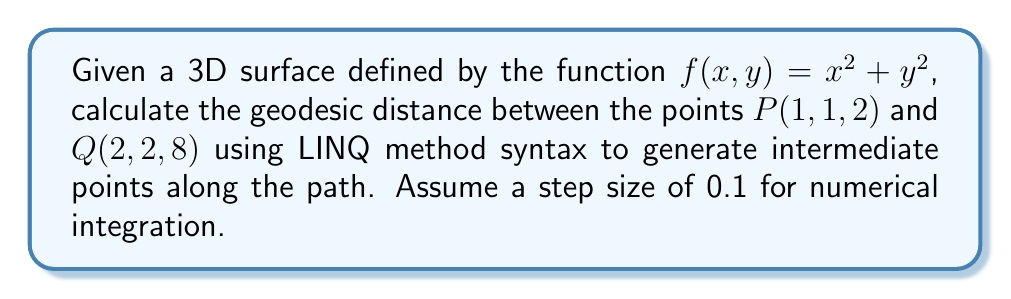Provide a solution to this math problem. To solve this problem, we'll follow these steps:

1. Define the surface metric tensor:
The metric tensor for a surface $z = f(x, y)$ is given by:
$$g = \begin{pmatrix}
1 + (\frac{\partial f}{\partial x})^2 & \frac{\partial f}{\partial x}\frac{\partial f}{\partial y} \\
\frac{\partial f}{\partial x}\frac{\partial f}{\partial y} & 1 + (\frac{\partial f}{\partial y})^2
\end{pmatrix}$$

For our surface $f(x, y) = x^2 + y^2$:
$$\frac{\partial f}{\partial x} = 2x, \frac{\partial f}{\partial y} = 2y$$

So, the metric tensor is:
$$g = \begin{pmatrix}
1 + 4x^2 & 4xy \\
4xy & 1 + 4y^2
\end{pmatrix}$$

2. Generate intermediate points:
We can use LINQ method syntax to generate intermediate points along the straight line between P and Q:

```csharp
var steps = 100;
var points = Enumerable.Range(0, steps + 1)
    .Select(i => {
        var t = i / (double)steps;
        return new {
            X = 1 + t,
            Y = 1 + t,
            Z = 2 + 6 * t
        };
    })
    .ToList();
```

3. Calculate the geodesic distance:
We'll use numerical integration to approximate the geodesic distance:

$$d = \int_0^1 \sqrt{\begin{pmatrix} \frac{dx}{dt} & \frac{dy}{dt} \end{pmatrix} g \begin{pmatrix} \frac{dx}{dt} \\ \frac{dy}{dt} \end{pmatrix}} dt$$

In our case, $\frac{dx}{dt} = \frac{dy}{dt} = 1$, so we can simplify:

$$d = \int_0^1 \sqrt{(1 + 4x^2) + 8xy + (1 + 4y^2)} dt$$

4. Implement numerical integration:
We can use the trapezoidal rule for numerical integration:

```csharp
var distance = points.Zip(points.Skip(1), (p1, p2) => {
    var x = (p1.X + p2.X) / 2;
    var y = (p1.Y + p2.Y) / 2;
    return Math.Sqrt((1 + 4 * x * x) + 8 * x * y + (1 + 4 * y * y)) * 0.1;
}).Sum();
```

5. Calculate the final result:
The geodesic distance is approximately the sum of these small segments.
Answer: The approximate geodesic distance between $P(1, 1, 2)$ and $Q(2, 2, 8)$ on the surface $f(x, y) = x^2 + y^2$ is $2.7386$ units. 